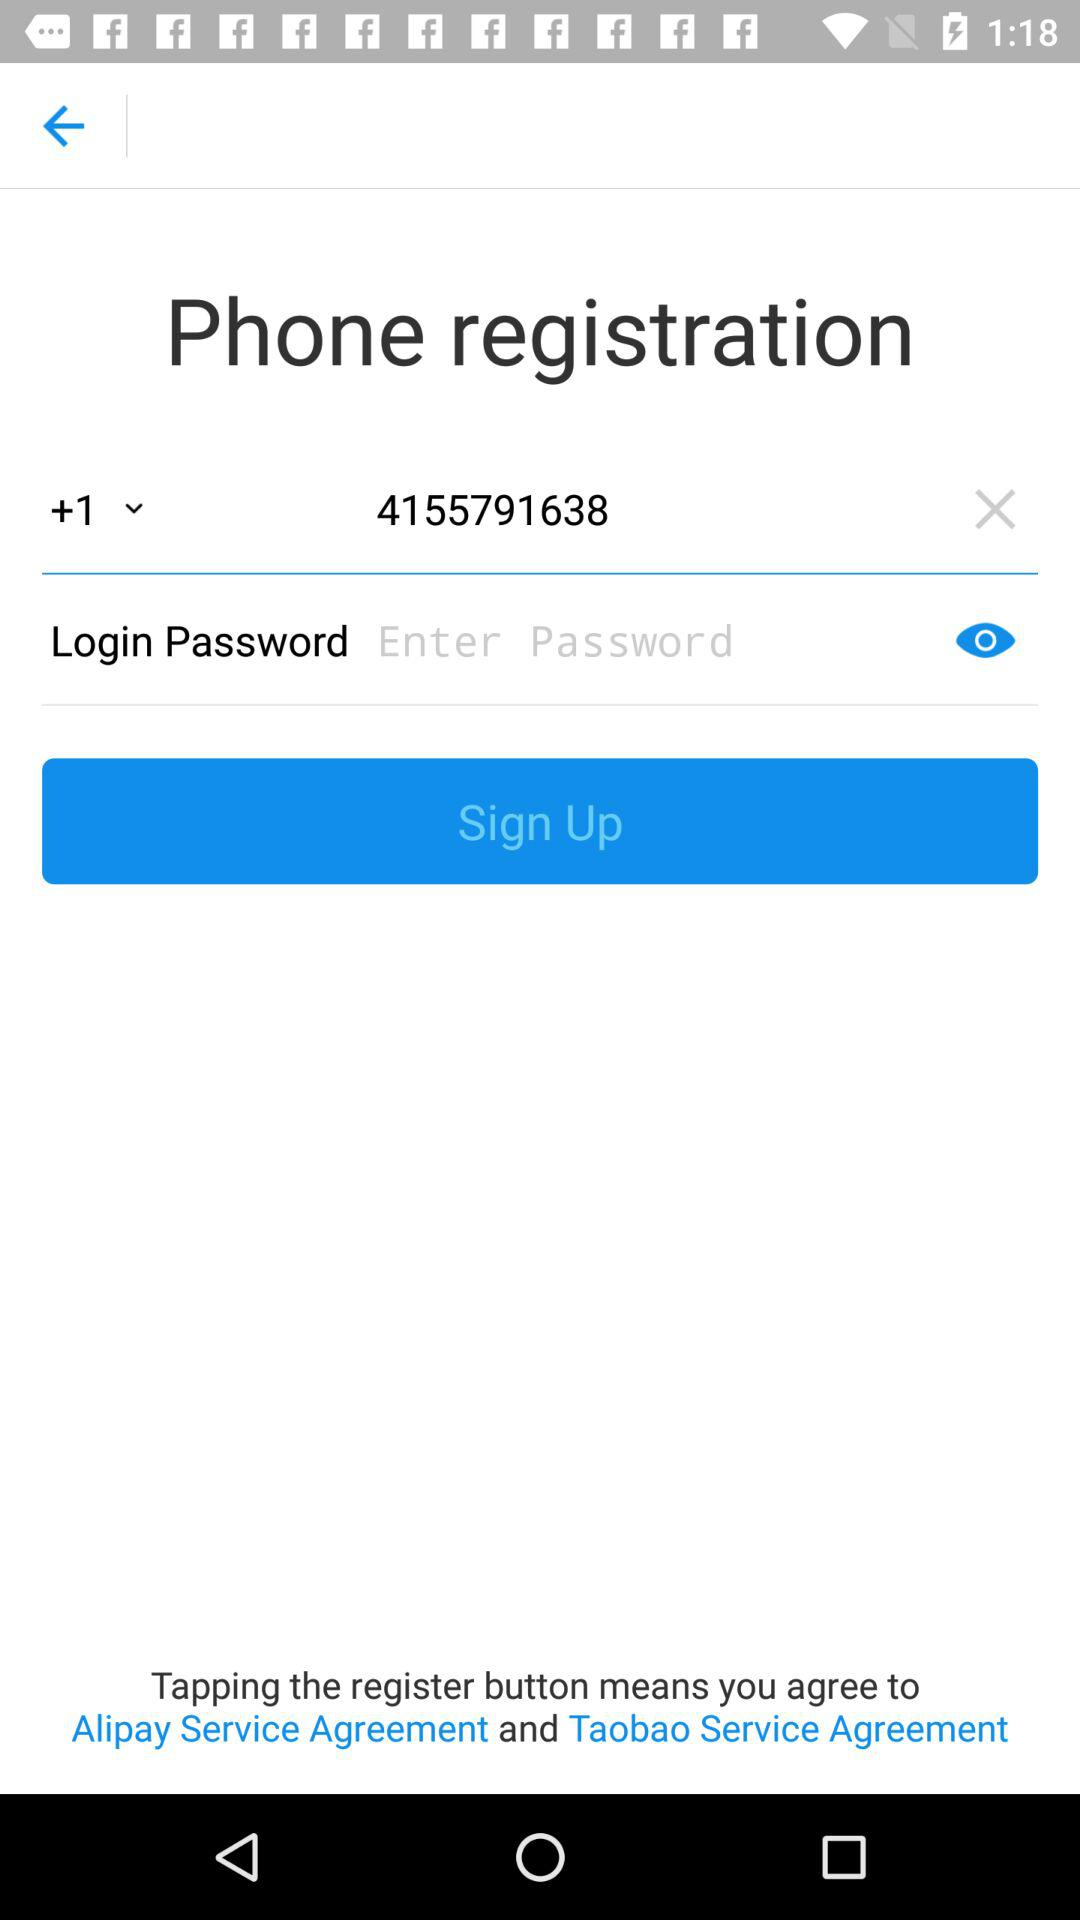What is the phone registration number? The phone registration number is +1 4155791638. 